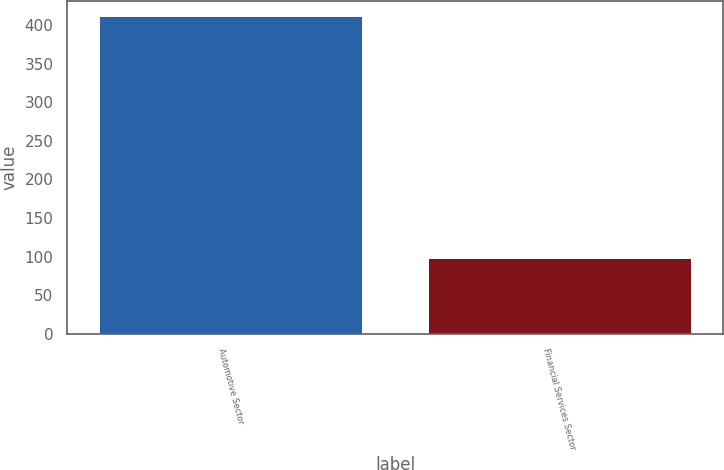<chart> <loc_0><loc_0><loc_500><loc_500><bar_chart><fcel>Automotive Sector<fcel>Financial Services Sector<nl><fcel>411<fcel>98<nl></chart> 